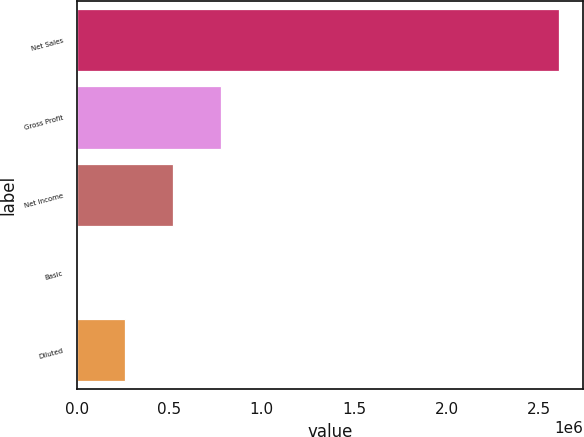<chart> <loc_0><loc_0><loc_500><loc_500><bar_chart><fcel>Net Sales<fcel>Gross Profit<fcel>Net Income<fcel>Basic<fcel>Diluted<nl><fcel>2.60676e+06<fcel>782028<fcel>521352<fcel>0.67<fcel>260676<nl></chart> 